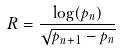Convert formula to latex. <formula><loc_0><loc_0><loc_500><loc_500>R = \frac { \log ( p _ { n } ) } { \sqrt { p _ { n + 1 } - p _ { n } } }</formula> 